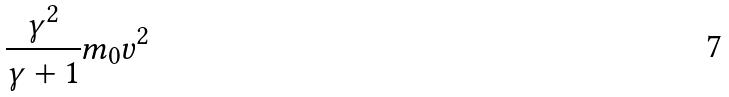Convert formula to latex. <formula><loc_0><loc_0><loc_500><loc_500>\frac { \gamma ^ { 2 } } { \gamma + 1 } m _ { 0 } v ^ { 2 }</formula> 